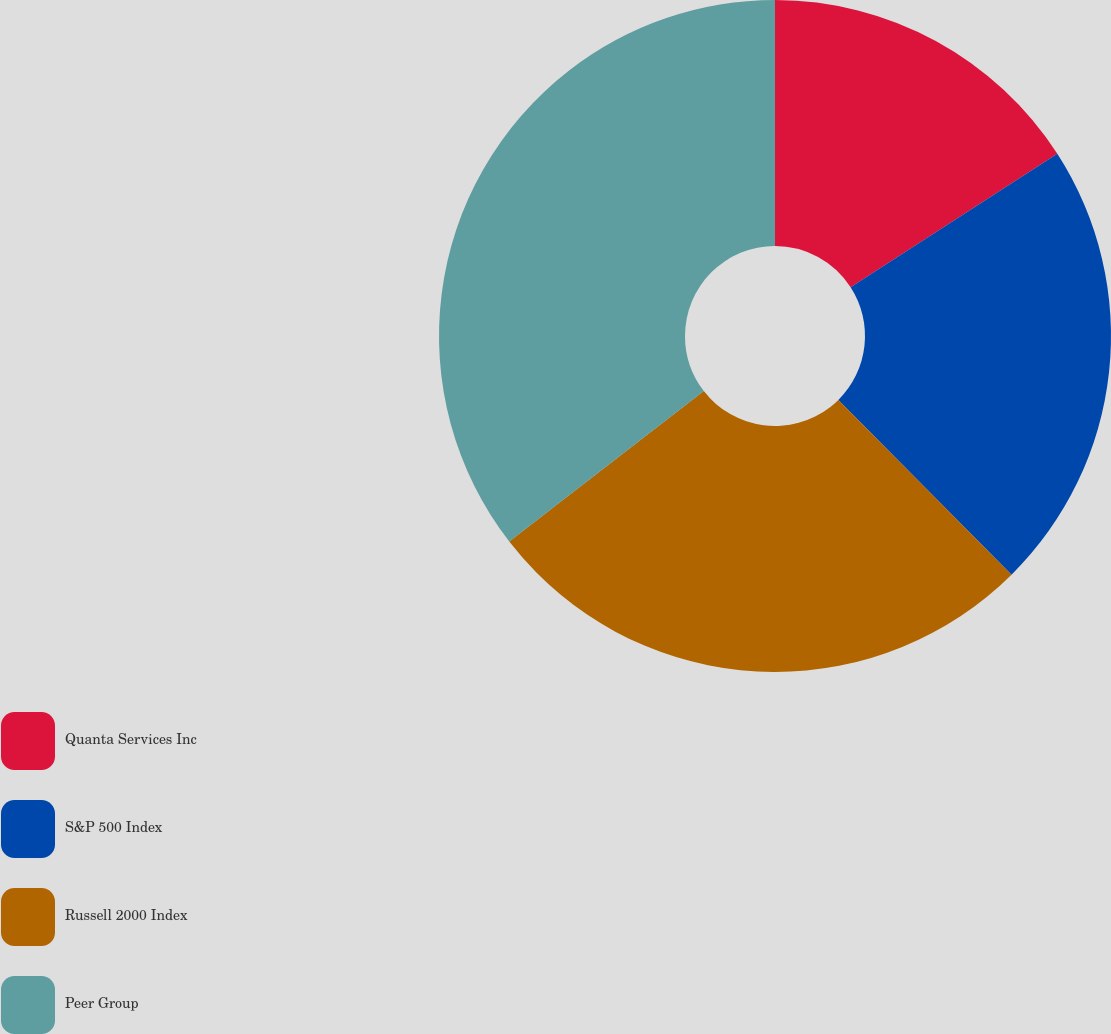<chart> <loc_0><loc_0><loc_500><loc_500><pie_chart><fcel>Quanta Services Inc<fcel>S&P 500 Index<fcel>Russell 2000 Index<fcel>Peer Group<nl><fcel>15.88%<fcel>21.69%<fcel>26.95%<fcel>35.48%<nl></chart> 